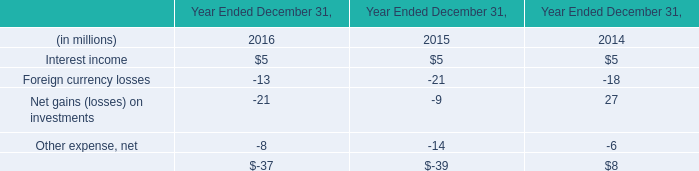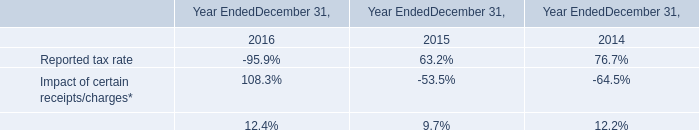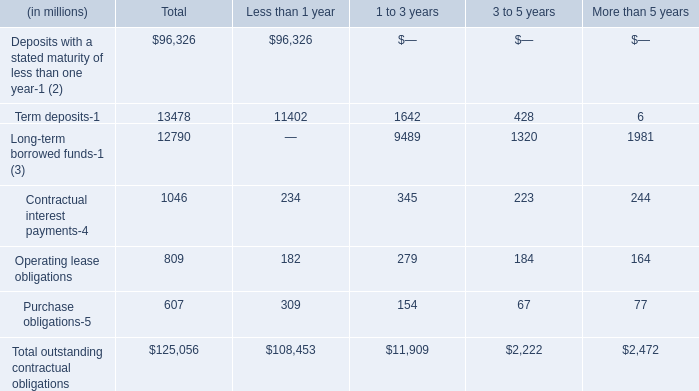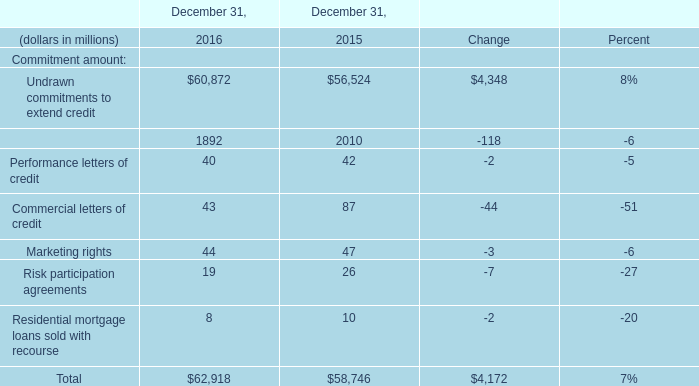When is Undrawn commitments to extend credit the largest? 
Answer: 2016. 